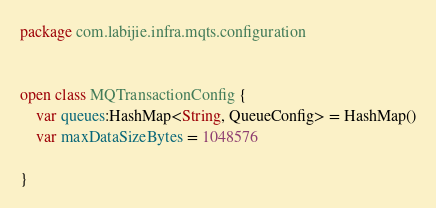Convert code to text. <code><loc_0><loc_0><loc_500><loc_500><_Kotlin_>package com.labijie.infra.mqts.configuration


open class MQTransactionConfig {
    var queues:HashMap<String, QueueConfig> = HashMap()
    var maxDataSizeBytes = 1048576

}</code> 